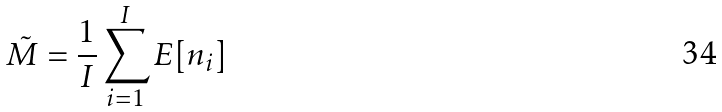<formula> <loc_0><loc_0><loc_500><loc_500>\tilde { M } = \frac { 1 } { I } \sum _ { i = 1 } ^ { I } E [ n _ { i } ]</formula> 